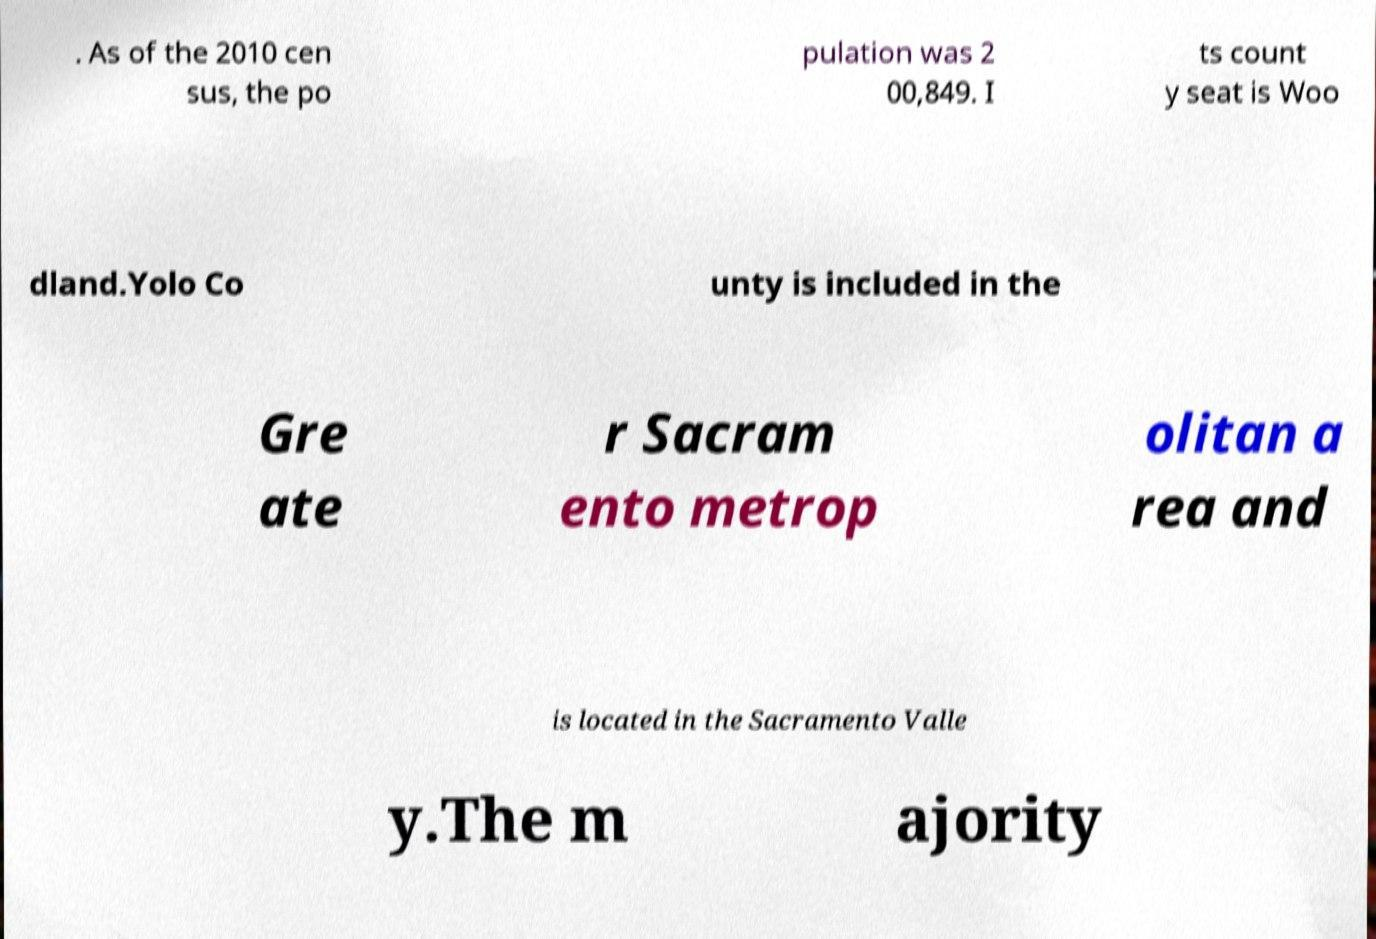Please identify and transcribe the text found in this image. . As of the 2010 cen sus, the po pulation was 2 00,849. I ts count y seat is Woo dland.Yolo Co unty is included in the Gre ate r Sacram ento metrop olitan a rea and is located in the Sacramento Valle y.The m ajority 